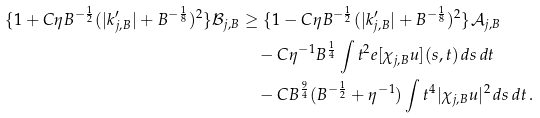<formula> <loc_0><loc_0><loc_500><loc_500>\{ 1 + C \eta B ^ { - \frac { 1 } { 2 } } ( | k _ { j , B } ^ { \prime } | + B ^ { - \frac { 1 } { 8 } } ) ^ { 2 } \} { \mathcal { B } } _ { j , B } & \geq \{ 1 - C \eta B ^ { - \frac { 1 } { 2 } } ( | k _ { j , B } ^ { \prime } | + B ^ { - \frac { 1 } { 8 } } ) ^ { 2 } \} { \mathcal { A } } _ { j , B } \\ & \quad - C \eta ^ { - 1 } B ^ { \frac { 1 } { 4 } } \int t ^ { 2 } e [ \chi _ { j , B } u ] ( s , t ) \, d s \, d t \\ & \quad - C B ^ { \frac { 9 } { 4 } } ( B ^ { - \frac { 1 } { 2 } } + \eta ^ { - 1 } ) \int t ^ { 4 } | \chi _ { j , B } u | ^ { 2 } \, d s \, d t \, .</formula> 